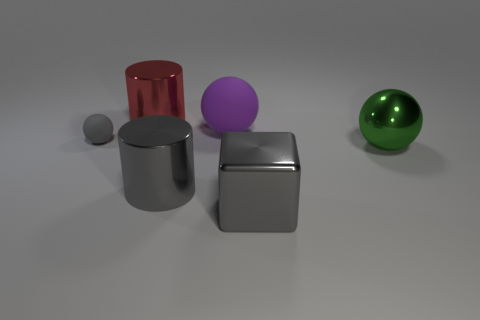Add 1 tiny cyan matte things. How many objects exist? 7 Subtract all large metal balls. How many balls are left? 2 Add 4 gray matte things. How many gray matte things are left? 5 Add 4 large green spheres. How many large green spheres exist? 5 Subtract all gray balls. How many balls are left? 2 Subtract 0 blue cubes. How many objects are left? 6 Subtract all blocks. How many objects are left? 5 Subtract all green cubes. Subtract all gray spheres. How many cubes are left? 1 Subtract all blue blocks. How many green balls are left? 1 Subtract all yellow rubber blocks. Subtract all purple things. How many objects are left? 5 